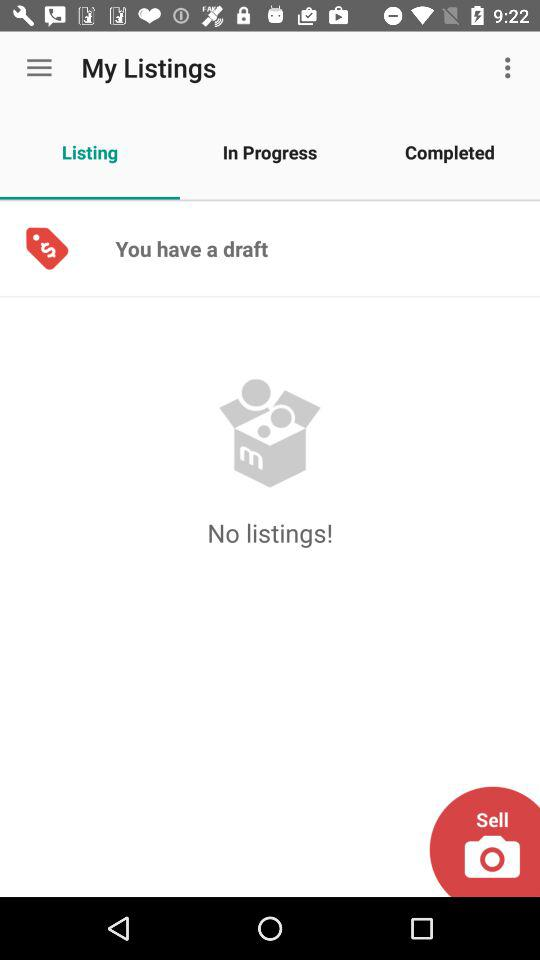What tab is selected? The selected tab is "Listing". 